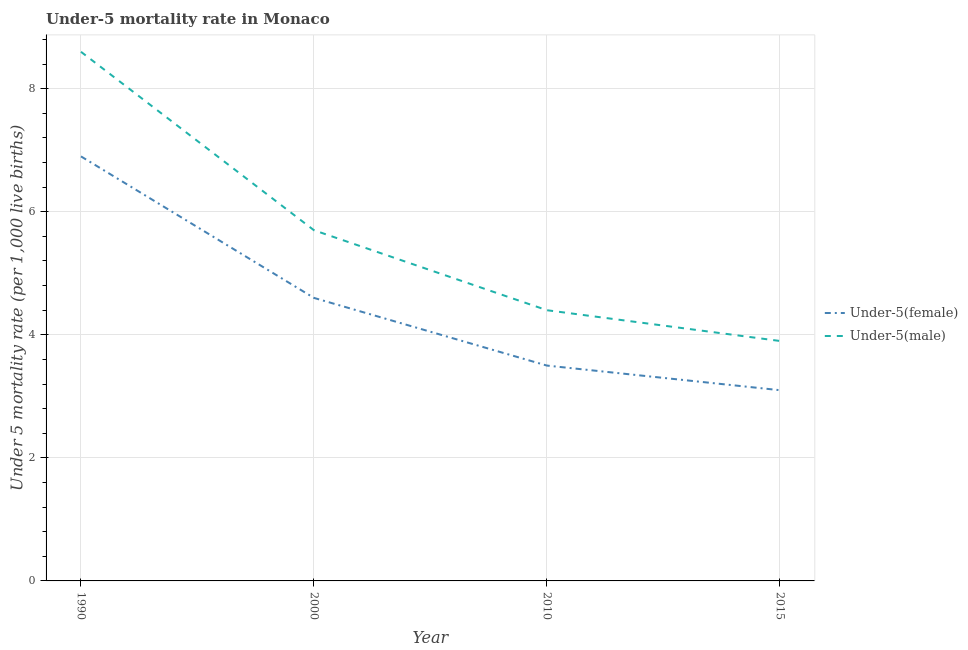How many different coloured lines are there?
Keep it short and to the point. 2. Is the number of lines equal to the number of legend labels?
Provide a succinct answer. Yes. What is the under-5 female mortality rate in 2010?
Your answer should be very brief. 3.5. In which year was the under-5 female mortality rate maximum?
Offer a terse response. 1990. In which year was the under-5 male mortality rate minimum?
Make the answer very short. 2015. What is the total under-5 male mortality rate in the graph?
Your response must be concise. 22.6. What is the difference between the under-5 male mortality rate in 2010 and that in 2015?
Keep it short and to the point. 0.5. What is the difference between the under-5 female mortality rate in 2015 and the under-5 male mortality rate in 2010?
Provide a succinct answer. -1.3. What is the average under-5 male mortality rate per year?
Your answer should be compact. 5.65. In the year 1990, what is the difference between the under-5 male mortality rate and under-5 female mortality rate?
Provide a succinct answer. 1.7. What is the ratio of the under-5 male mortality rate in 1990 to that in 2015?
Offer a terse response. 2.21. Is the under-5 male mortality rate in 2010 less than that in 2015?
Your response must be concise. No. What is the difference between the highest and the second highest under-5 male mortality rate?
Your response must be concise. 2.9. What is the difference between the highest and the lowest under-5 male mortality rate?
Provide a short and direct response. 4.7. Is the sum of the under-5 male mortality rate in 2000 and 2015 greater than the maximum under-5 female mortality rate across all years?
Keep it short and to the point. Yes. Is the under-5 female mortality rate strictly greater than the under-5 male mortality rate over the years?
Give a very brief answer. No. How many lines are there?
Offer a very short reply. 2. How many years are there in the graph?
Ensure brevity in your answer.  4. What is the difference between two consecutive major ticks on the Y-axis?
Ensure brevity in your answer.  2. Are the values on the major ticks of Y-axis written in scientific E-notation?
Your response must be concise. No. Does the graph contain grids?
Make the answer very short. Yes. Where does the legend appear in the graph?
Give a very brief answer. Center right. How many legend labels are there?
Your response must be concise. 2. How are the legend labels stacked?
Provide a short and direct response. Vertical. What is the title of the graph?
Offer a very short reply. Under-5 mortality rate in Monaco. What is the label or title of the Y-axis?
Offer a terse response. Under 5 mortality rate (per 1,0 live births). What is the Under 5 mortality rate (per 1,000 live births) in Under-5(female) in 1990?
Keep it short and to the point. 6.9. What is the Under 5 mortality rate (per 1,000 live births) in Under-5(male) in 1990?
Provide a short and direct response. 8.6. What is the Under 5 mortality rate (per 1,000 live births) of Under-5(female) in 2000?
Your response must be concise. 4.6. Across all years, what is the maximum Under 5 mortality rate (per 1,000 live births) of Under-5(female)?
Offer a very short reply. 6.9. Across all years, what is the maximum Under 5 mortality rate (per 1,000 live births) in Under-5(male)?
Give a very brief answer. 8.6. Across all years, what is the minimum Under 5 mortality rate (per 1,000 live births) of Under-5(female)?
Offer a very short reply. 3.1. Across all years, what is the minimum Under 5 mortality rate (per 1,000 live births) in Under-5(male)?
Ensure brevity in your answer.  3.9. What is the total Under 5 mortality rate (per 1,000 live births) in Under-5(male) in the graph?
Ensure brevity in your answer.  22.6. What is the difference between the Under 5 mortality rate (per 1,000 live births) in Under-5(female) in 1990 and that in 2000?
Your answer should be compact. 2.3. What is the difference between the Under 5 mortality rate (per 1,000 live births) in Under-5(female) in 1990 and that in 2010?
Offer a terse response. 3.4. What is the difference between the Under 5 mortality rate (per 1,000 live births) of Under-5(female) in 1990 and that in 2015?
Offer a very short reply. 3.8. What is the difference between the Under 5 mortality rate (per 1,000 live births) of Under-5(male) in 1990 and that in 2015?
Give a very brief answer. 4.7. What is the difference between the Under 5 mortality rate (per 1,000 live births) in Under-5(female) in 2000 and that in 2010?
Keep it short and to the point. 1.1. What is the difference between the Under 5 mortality rate (per 1,000 live births) in Under-5(female) in 1990 and the Under 5 mortality rate (per 1,000 live births) in Under-5(male) in 2000?
Provide a short and direct response. 1.2. What is the difference between the Under 5 mortality rate (per 1,000 live births) in Under-5(female) in 1990 and the Under 5 mortality rate (per 1,000 live births) in Under-5(male) in 2015?
Offer a terse response. 3. What is the difference between the Under 5 mortality rate (per 1,000 live births) in Under-5(female) in 2000 and the Under 5 mortality rate (per 1,000 live births) in Under-5(male) in 2010?
Your response must be concise. 0.2. What is the average Under 5 mortality rate (per 1,000 live births) in Under-5(female) per year?
Give a very brief answer. 4.53. What is the average Under 5 mortality rate (per 1,000 live births) of Under-5(male) per year?
Offer a very short reply. 5.65. In the year 1990, what is the difference between the Under 5 mortality rate (per 1,000 live births) of Under-5(female) and Under 5 mortality rate (per 1,000 live births) of Under-5(male)?
Make the answer very short. -1.7. In the year 2015, what is the difference between the Under 5 mortality rate (per 1,000 live births) of Under-5(female) and Under 5 mortality rate (per 1,000 live births) of Under-5(male)?
Make the answer very short. -0.8. What is the ratio of the Under 5 mortality rate (per 1,000 live births) in Under-5(female) in 1990 to that in 2000?
Your answer should be very brief. 1.5. What is the ratio of the Under 5 mortality rate (per 1,000 live births) in Under-5(male) in 1990 to that in 2000?
Ensure brevity in your answer.  1.51. What is the ratio of the Under 5 mortality rate (per 1,000 live births) of Under-5(female) in 1990 to that in 2010?
Ensure brevity in your answer.  1.97. What is the ratio of the Under 5 mortality rate (per 1,000 live births) in Under-5(male) in 1990 to that in 2010?
Ensure brevity in your answer.  1.95. What is the ratio of the Under 5 mortality rate (per 1,000 live births) of Under-5(female) in 1990 to that in 2015?
Your answer should be very brief. 2.23. What is the ratio of the Under 5 mortality rate (per 1,000 live births) of Under-5(male) in 1990 to that in 2015?
Offer a terse response. 2.21. What is the ratio of the Under 5 mortality rate (per 1,000 live births) in Under-5(female) in 2000 to that in 2010?
Your answer should be very brief. 1.31. What is the ratio of the Under 5 mortality rate (per 1,000 live births) in Under-5(male) in 2000 to that in 2010?
Your response must be concise. 1.3. What is the ratio of the Under 5 mortality rate (per 1,000 live births) in Under-5(female) in 2000 to that in 2015?
Make the answer very short. 1.48. What is the ratio of the Under 5 mortality rate (per 1,000 live births) of Under-5(male) in 2000 to that in 2015?
Provide a succinct answer. 1.46. What is the ratio of the Under 5 mortality rate (per 1,000 live births) in Under-5(female) in 2010 to that in 2015?
Your answer should be compact. 1.13. What is the ratio of the Under 5 mortality rate (per 1,000 live births) of Under-5(male) in 2010 to that in 2015?
Ensure brevity in your answer.  1.13. 